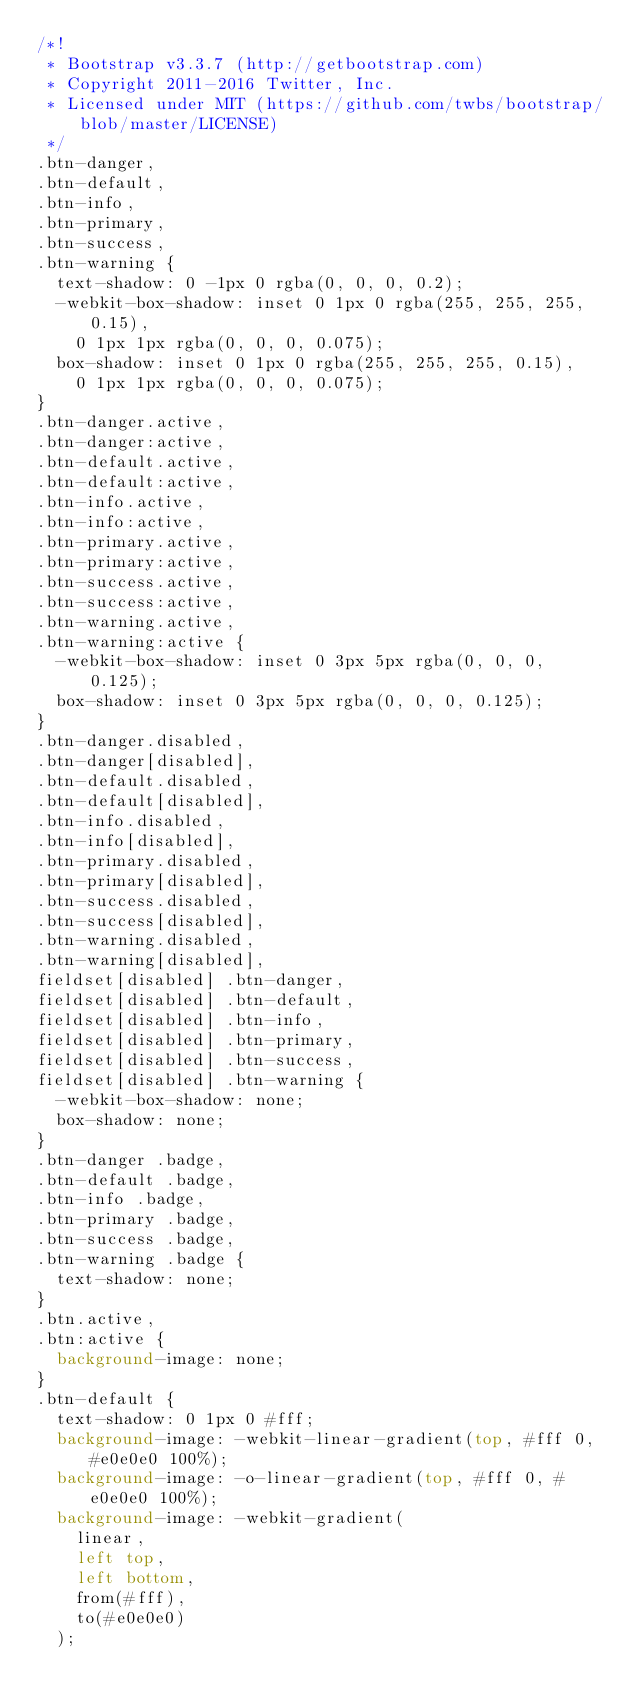Convert code to text. <code><loc_0><loc_0><loc_500><loc_500><_CSS_>/*!
 * Bootstrap v3.3.7 (http://getbootstrap.com)
 * Copyright 2011-2016 Twitter, Inc.
 * Licensed under MIT (https://github.com/twbs/bootstrap/blob/master/LICENSE)
 */
.btn-danger,
.btn-default,
.btn-info,
.btn-primary,
.btn-success,
.btn-warning {
  text-shadow: 0 -1px 0 rgba(0, 0, 0, 0.2);
  -webkit-box-shadow: inset 0 1px 0 rgba(255, 255, 255, 0.15),
    0 1px 1px rgba(0, 0, 0, 0.075);
  box-shadow: inset 0 1px 0 rgba(255, 255, 255, 0.15),
    0 1px 1px rgba(0, 0, 0, 0.075);
}
.btn-danger.active,
.btn-danger:active,
.btn-default.active,
.btn-default:active,
.btn-info.active,
.btn-info:active,
.btn-primary.active,
.btn-primary:active,
.btn-success.active,
.btn-success:active,
.btn-warning.active,
.btn-warning:active {
  -webkit-box-shadow: inset 0 3px 5px rgba(0, 0, 0, 0.125);
  box-shadow: inset 0 3px 5px rgba(0, 0, 0, 0.125);
}
.btn-danger.disabled,
.btn-danger[disabled],
.btn-default.disabled,
.btn-default[disabled],
.btn-info.disabled,
.btn-info[disabled],
.btn-primary.disabled,
.btn-primary[disabled],
.btn-success.disabled,
.btn-success[disabled],
.btn-warning.disabled,
.btn-warning[disabled],
fieldset[disabled] .btn-danger,
fieldset[disabled] .btn-default,
fieldset[disabled] .btn-info,
fieldset[disabled] .btn-primary,
fieldset[disabled] .btn-success,
fieldset[disabled] .btn-warning {
  -webkit-box-shadow: none;
  box-shadow: none;
}
.btn-danger .badge,
.btn-default .badge,
.btn-info .badge,
.btn-primary .badge,
.btn-success .badge,
.btn-warning .badge {
  text-shadow: none;
}
.btn.active,
.btn:active {
  background-image: none;
}
.btn-default {
  text-shadow: 0 1px 0 #fff;
  background-image: -webkit-linear-gradient(top, #fff 0, #e0e0e0 100%);
  background-image: -o-linear-gradient(top, #fff 0, #e0e0e0 100%);
  background-image: -webkit-gradient(
    linear,
    left top,
    left bottom,
    from(#fff),
    to(#e0e0e0)
  );</code> 